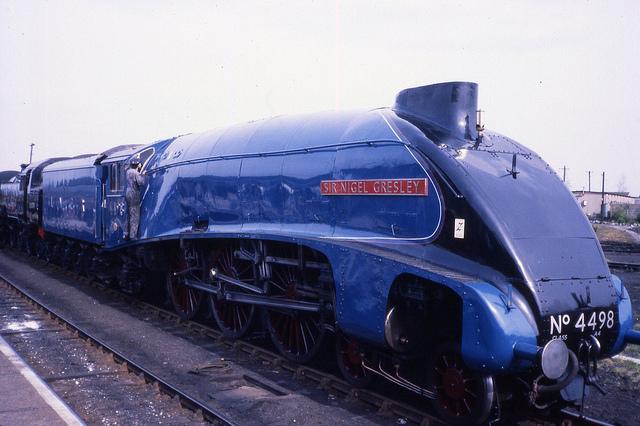What number is written in front of the train?
Quick response, please. 4498. How many people are around?
Short answer required. 1. What is the train's number?
Quick response, please. 4498. 